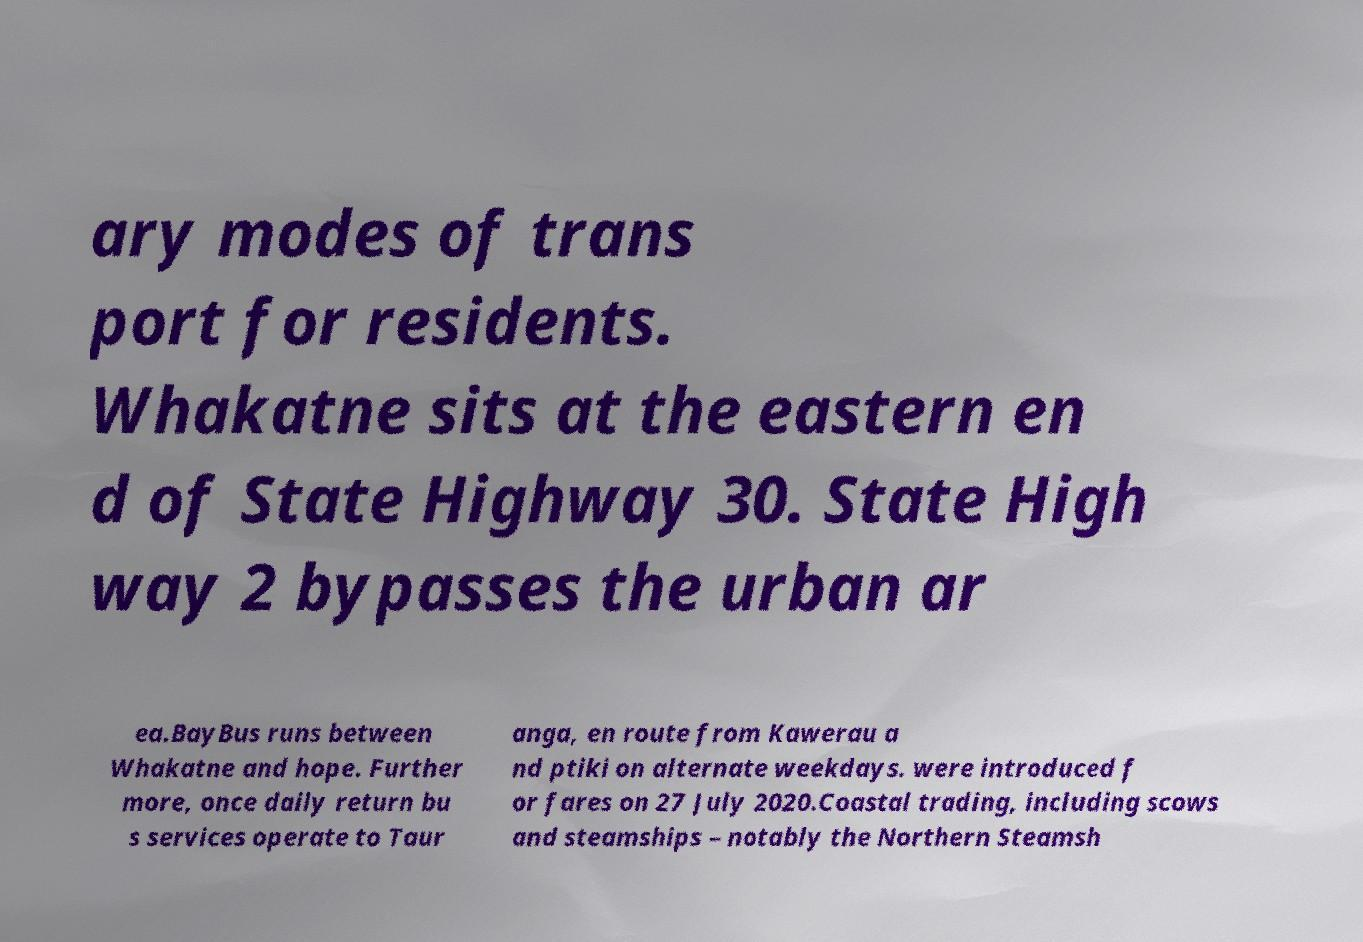I need the written content from this picture converted into text. Can you do that? ary modes of trans port for residents. Whakatne sits at the eastern en d of State Highway 30. State High way 2 bypasses the urban ar ea.BayBus runs between Whakatne and hope. Further more, once daily return bu s services operate to Taur anga, en route from Kawerau a nd ptiki on alternate weekdays. were introduced f or fares on 27 July 2020.Coastal trading, including scows and steamships – notably the Northern Steamsh 